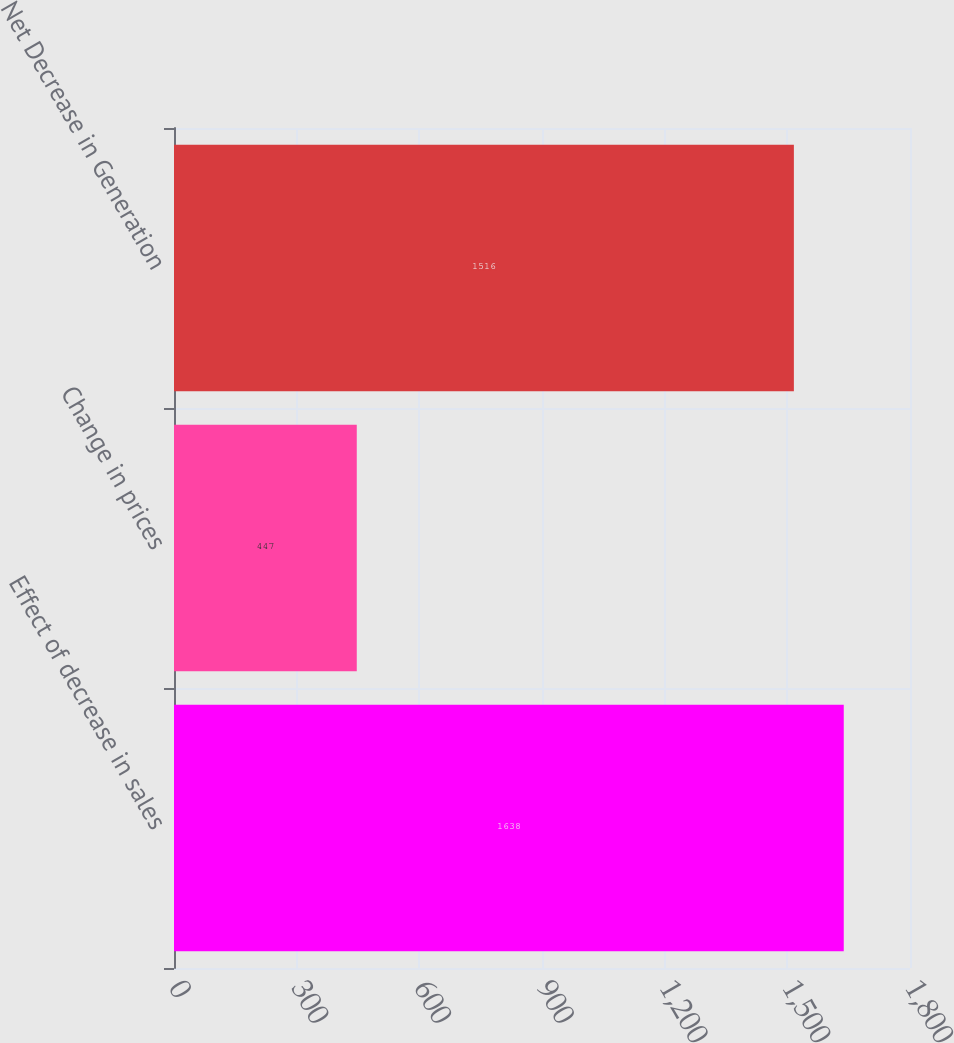Convert chart. <chart><loc_0><loc_0><loc_500><loc_500><bar_chart><fcel>Effect of decrease in sales<fcel>Change in prices<fcel>Net Decrease in Generation<nl><fcel>1638<fcel>447<fcel>1516<nl></chart> 